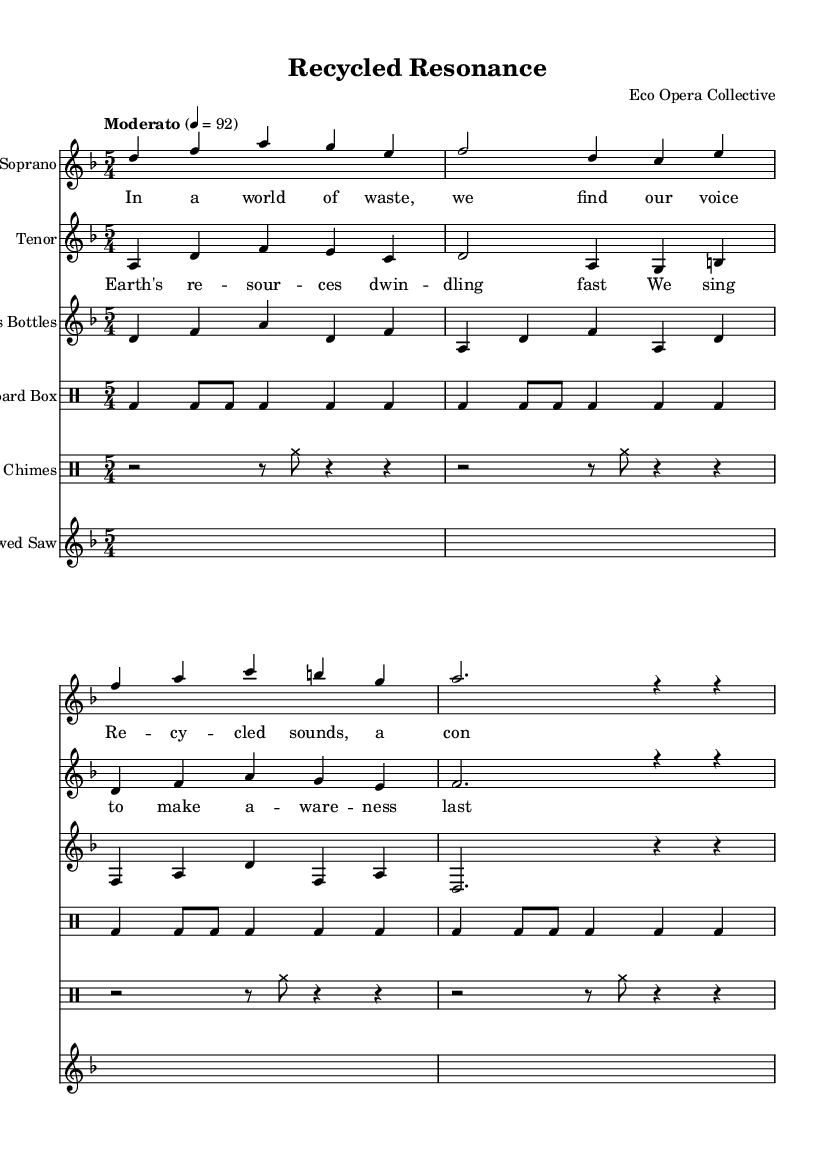What is the key signature of this music? The key signature is indicated by the sharp or flat symbols at the beginning of the staff. In this case, the key of D minor is represented, which has one flat (B flat).
Answer: D minor What is the time signature of this music? The time signature is shown as a fraction at the beginning of the staff. Here, it is 5/4, indicating five beats per measure and a quarter note receives one beat.
Answer: 5/4 What is the tempo marking? The tempo marking is often indicated in Italian words in the score. Here it states "Moderato" indicating a moderate speed of music at the marking of "4 = 92," meaning there are 92 beats per minute.
Answer: Moderato How many instruments are used in this opera? By counting the distinct staves and their notations, we can determine the number of voices and instruments used. In this score, there are five distinct parts: Soprano, Tenor, Glass Bottles, Cardboard Box, Wind Chimes, and Bowed Saw, totaling six instruments.
Answer: Six What unique materials are highlighted in the staging of this opera? By observing the content of the score, we see the presence of sounds generated from Glass Bottles, Cardboard Boxes, Wind Chimes, and a Bowed Saw, which are eco-friendly materials incorporated into the staging.
Answer: Glass Bottles, Cardboard Box, Wind Chimes, Bowed Saw What is the primary theme expressed in the lyrics? Analyzing the lyrics of both the Soprano and Tenor parts, the central theme revolves around environmental awareness and recycling, emphasizing the importance of consciousness toward waste and resource depletion.
Answer: Environmental awareness and recycling 